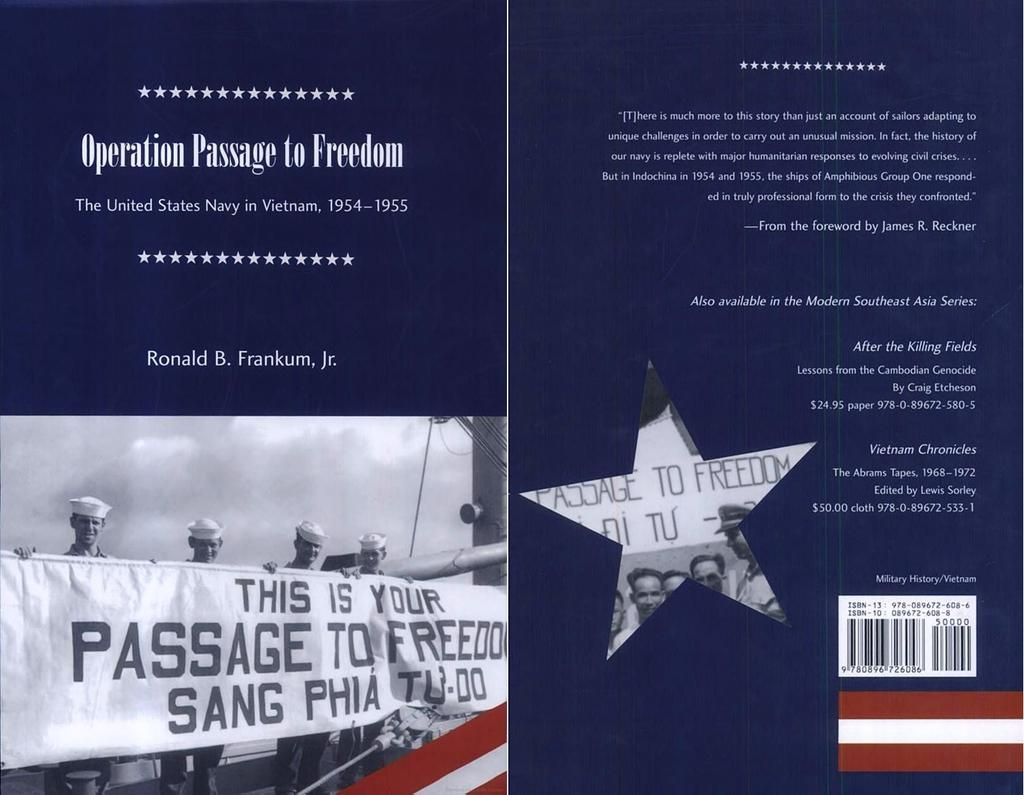<image>
Give a short and clear explanation of the subsequent image. The cover of the book entitled operation passage to freedom. 